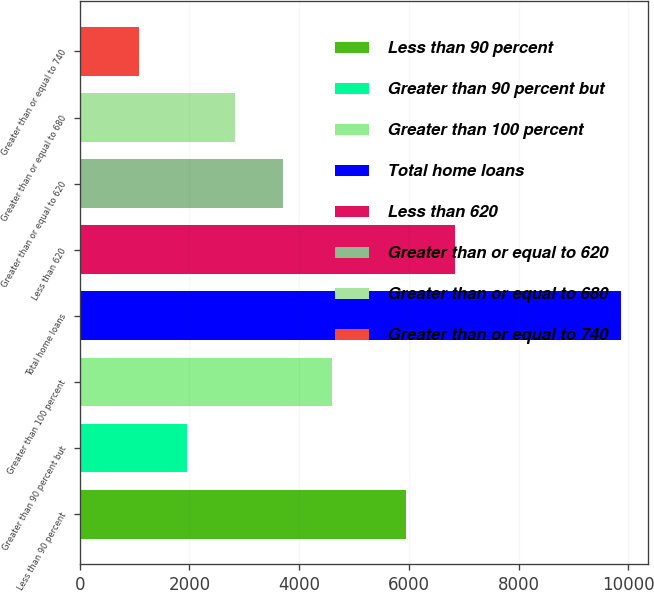<chart> <loc_0><loc_0><loc_500><loc_500><bar_chart><fcel>Less than 90 percent<fcel>Greater than 90 percent but<fcel>Greater than 100 percent<fcel>Total home loans<fcel>Less than 620<fcel>Greater than or equal to 620<fcel>Greater than or equal to 680<fcel>Greater than or equal to 740<nl><fcel>5953<fcel>1957.7<fcel>4590.8<fcel>9857<fcel>6830.7<fcel>3713.1<fcel>2835.4<fcel>1080<nl></chart> 